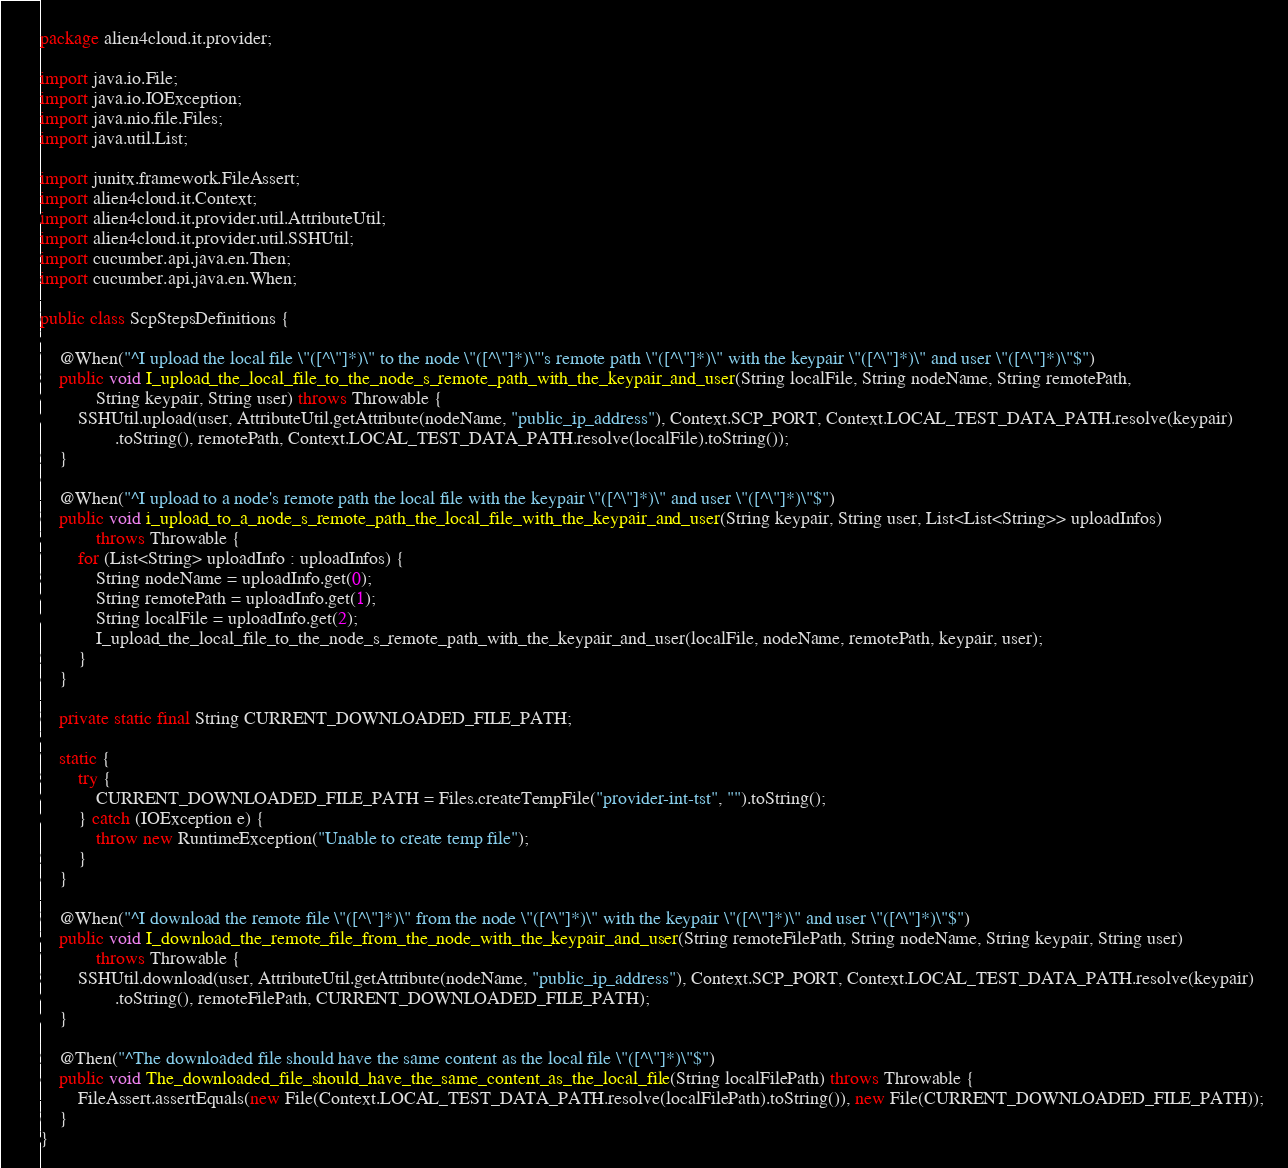<code> <loc_0><loc_0><loc_500><loc_500><_Java_>package alien4cloud.it.provider;

import java.io.File;
import java.io.IOException;
import java.nio.file.Files;
import java.util.List;

import junitx.framework.FileAssert;
import alien4cloud.it.Context;
import alien4cloud.it.provider.util.AttributeUtil;
import alien4cloud.it.provider.util.SSHUtil;
import cucumber.api.java.en.Then;
import cucumber.api.java.en.When;

public class ScpStepsDefinitions {

    @When("^I upload the local file \"([^\"]*)\" to the node \"([^\"]*)\"'s remote path \"([^\"]*)\" with the keypair \"([^\"]*)\" and user \"([^\"]*)\"$")
    public void I_upload_the_local_file_to_the_node_s_remote_path_with_the_keypair_and_user(String localFile, String nodeName, String remotePath,
            String keypair, String user) throws Throwable {
        SSHUtil.upload(user, AttributeUtil.getAttribute(nodeName, "public_ip_address"), Context.SCP_PORT, Context.LOCAL_TEST_DATA_PATH.resolve(keypair)
                .toString(), remotePath, Context.LOCAL_TEST_DATA_PATH.resolve(localFile).toString());
    }

    @When("^I upload to a node's remote path the local file with the keypair \"([^\"]*)\" and user \"([^\"]*)\"$")
    public void i_upload_to_a_node_s_remote_path_the_local_file_with_the_keypair_and_user(String keypair, String user, List<List<String>> uploadInfos)
            throws Throwable {
        for (List<String> uploadInfo : uploadInfos) {
            String nodeName = uploadInfo.get(0);
            String remotePath = uploadInfo.get(1);
            String localFile = uploadInfo.get(2);
            I_upload_the_local_file_to_the_node_s_remote_path_with_the_keypair_and_user(localFile, nodeName, remotePath, keypair, user);
        }
    }

    private static final String CURRENT_DOWNLOADED_FILE_PATH;

    static {
        try {
            CURRENT_DOWNLOADED_FILE_PATH = Files.createTempFile("provider-int-tst", "").toString();
        } catch (IOException e) {
            throw new RuntimeException("Unable to create temp file");
        }
    }

    @When("^I download the remote file \"([^\"]*)\" from the node \"([^\"]*)\" with the keypair \"([^\"]*)\" and user \"([^\"]*)\"$")
    public void I_download_the_remote_file_from_the_node_with_the_keypair_and_user(String remoteFilePath, String nodeName, String keypair, String user)
            throws Throwable {
        SSHUtil.download(user, AttributeUtil.getAttribute(nodeName, "public_ip_address"), Context.SCP_PORT, Context.LOCAL_TEST_DATA_PATH.resolve(keypair)
                .toString(), remoteFilePath, CURRENT_DOWNLOADED_FILE_PATH);
    }

    @Then("^The downloaded file should have the same content as the local file \"([^\"]*)\"$")
    public void The_downloaded_file_should_have_the_same_content_as_the_local_file(String localFilePath) throws Throwable {
        FileAssert.assertEquals(new File(Context.LOCAL_TEST_DATA_PATH.resolve(localFilePath).toString()), new File(CURRENT_DOWNLOADED_FILE_PATH));
    }
}
</code> 